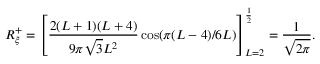Convert formula to latex. <formula><loc_0><loc_0><loc_500><loc_500>R _ { \xi } ^ { + } = \left [ \frac { 2 ( L + 1 ) ( L + 4 ) } { 9 \pi \sqrt { 3 } L ^ { 2 } } \cos ( \pi ( L - 4 ) / 6 L ) \right ] _ { L = 2 } ^ { \frac { 1 } { 2 } } = \frac { 1 } { \sqrt { 2 \pi } } .</formula> 